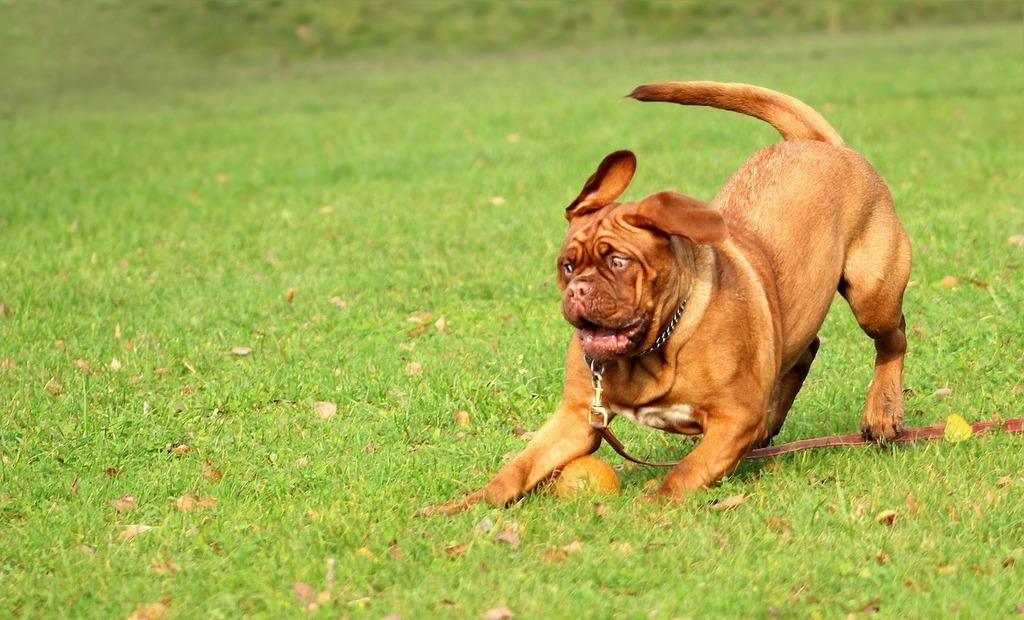What type of animal is in the picture? There is a dog in the picture. What color is the dog? The dog is brown in color. What object is on the grass in the image? There is a ball on the grass. What type of surface is visible in the image? Grass is present in the image. What can be seen at the bottom of the image? Dried leaves are visible at the bottom of the image. What is the price of the dog in the image? The image does not provide information about the price of the dog, as it is not a commercial transaction. 